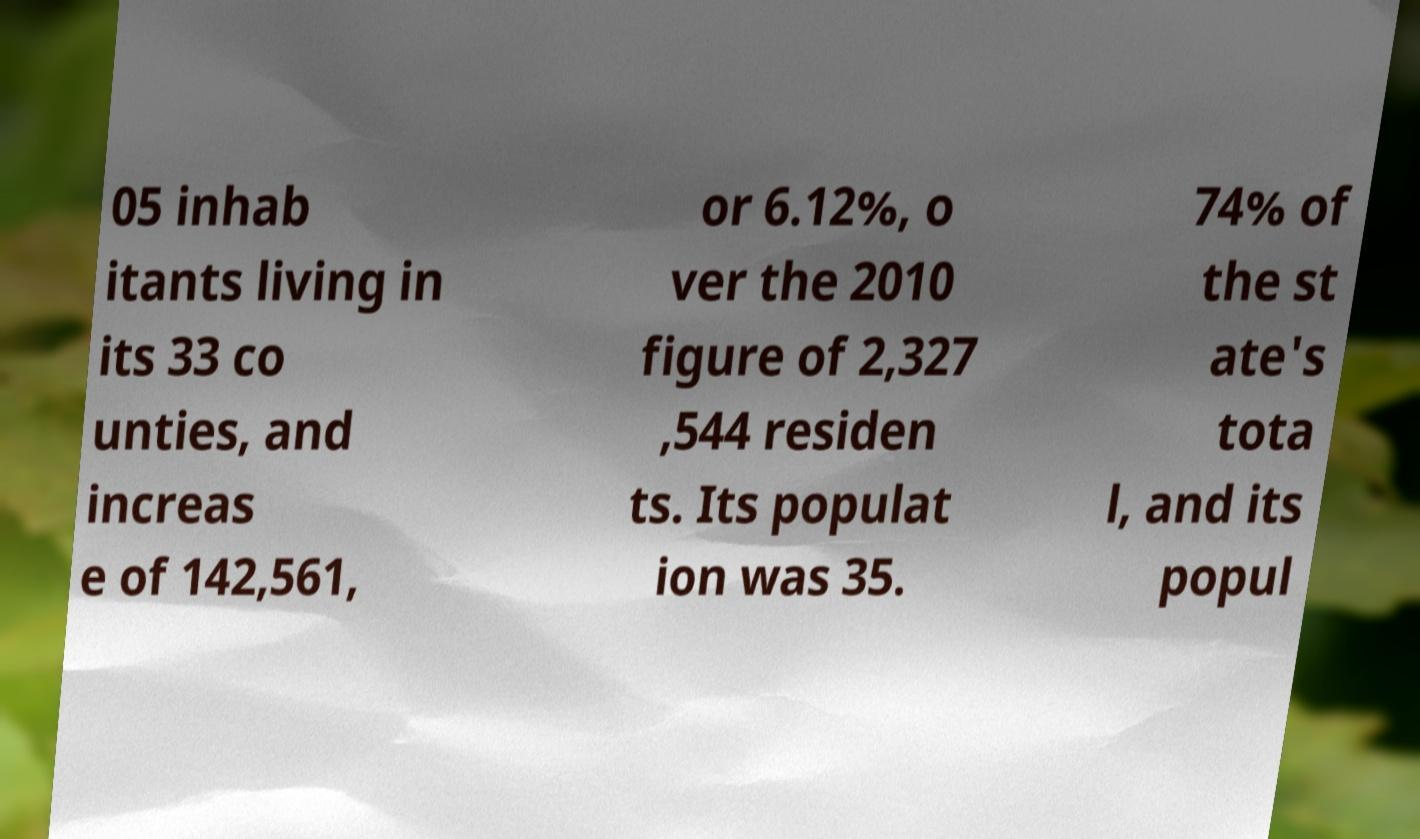There's text embedded in this image that I need extracted. Can you transcribe it verbatim? 05 inhab itants living in its 33 co unties, and increas e of 142,561, or 6.12%, o ver the 2010 figure of 2,327 ,544 residen ts. Its populat ion was 35. 74% of the st ate's tota l, and its popul 